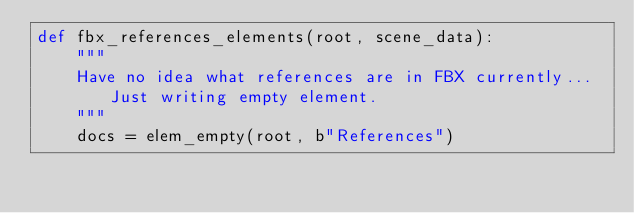Convert code to text. <code><loc_0><loc_0><loc_500><loc_500><_Python_>def fbx_references_elements(root, scene_data):
    """
    Have no idea what references are in FBX currently... Just writing empty element.
    """
    docs = elem_empty(root, b"References")


</code> 